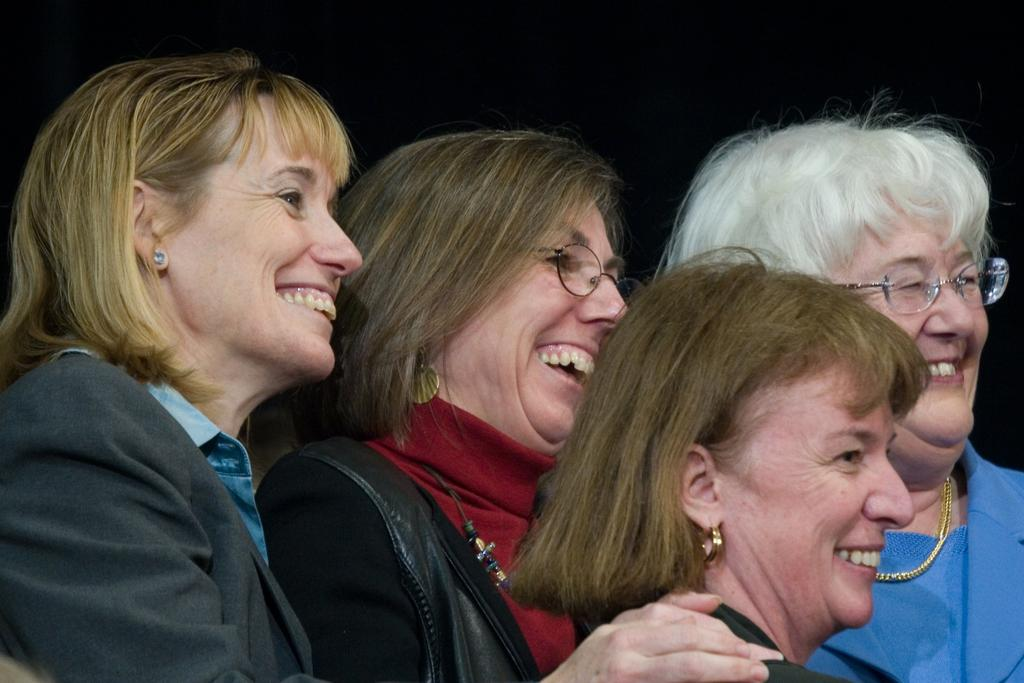Who is present in the picture? There are old women in the picture. Where are the old women positioned in the image? The old women are standing in the front. What expression do the old women have? The old women are smiling. What direction are the old women looking? The old women are looking to the right side. What is the color of the background in the image? There is a black background in the image. What type of letter is being passed between the old women in the image? There is no letter present in the image; the old women are simply standing and smiling. 